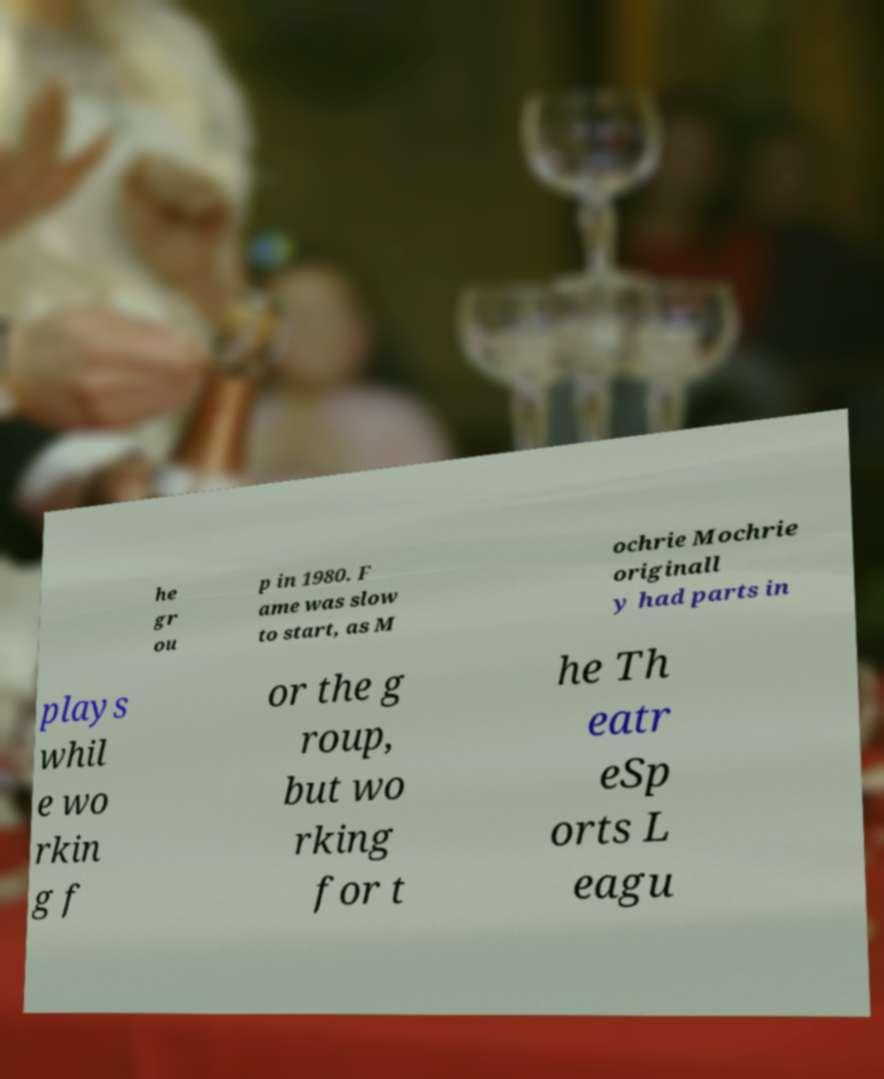Please identify and transcribe the text found in this image. he gr ou p in 1980. F ame was slow to start, as M ochrie Mochrie originall y had parts in plays whil e wo rkin g f or the g roup, but wo rking for t he Th eatr eSp orts L eagu 